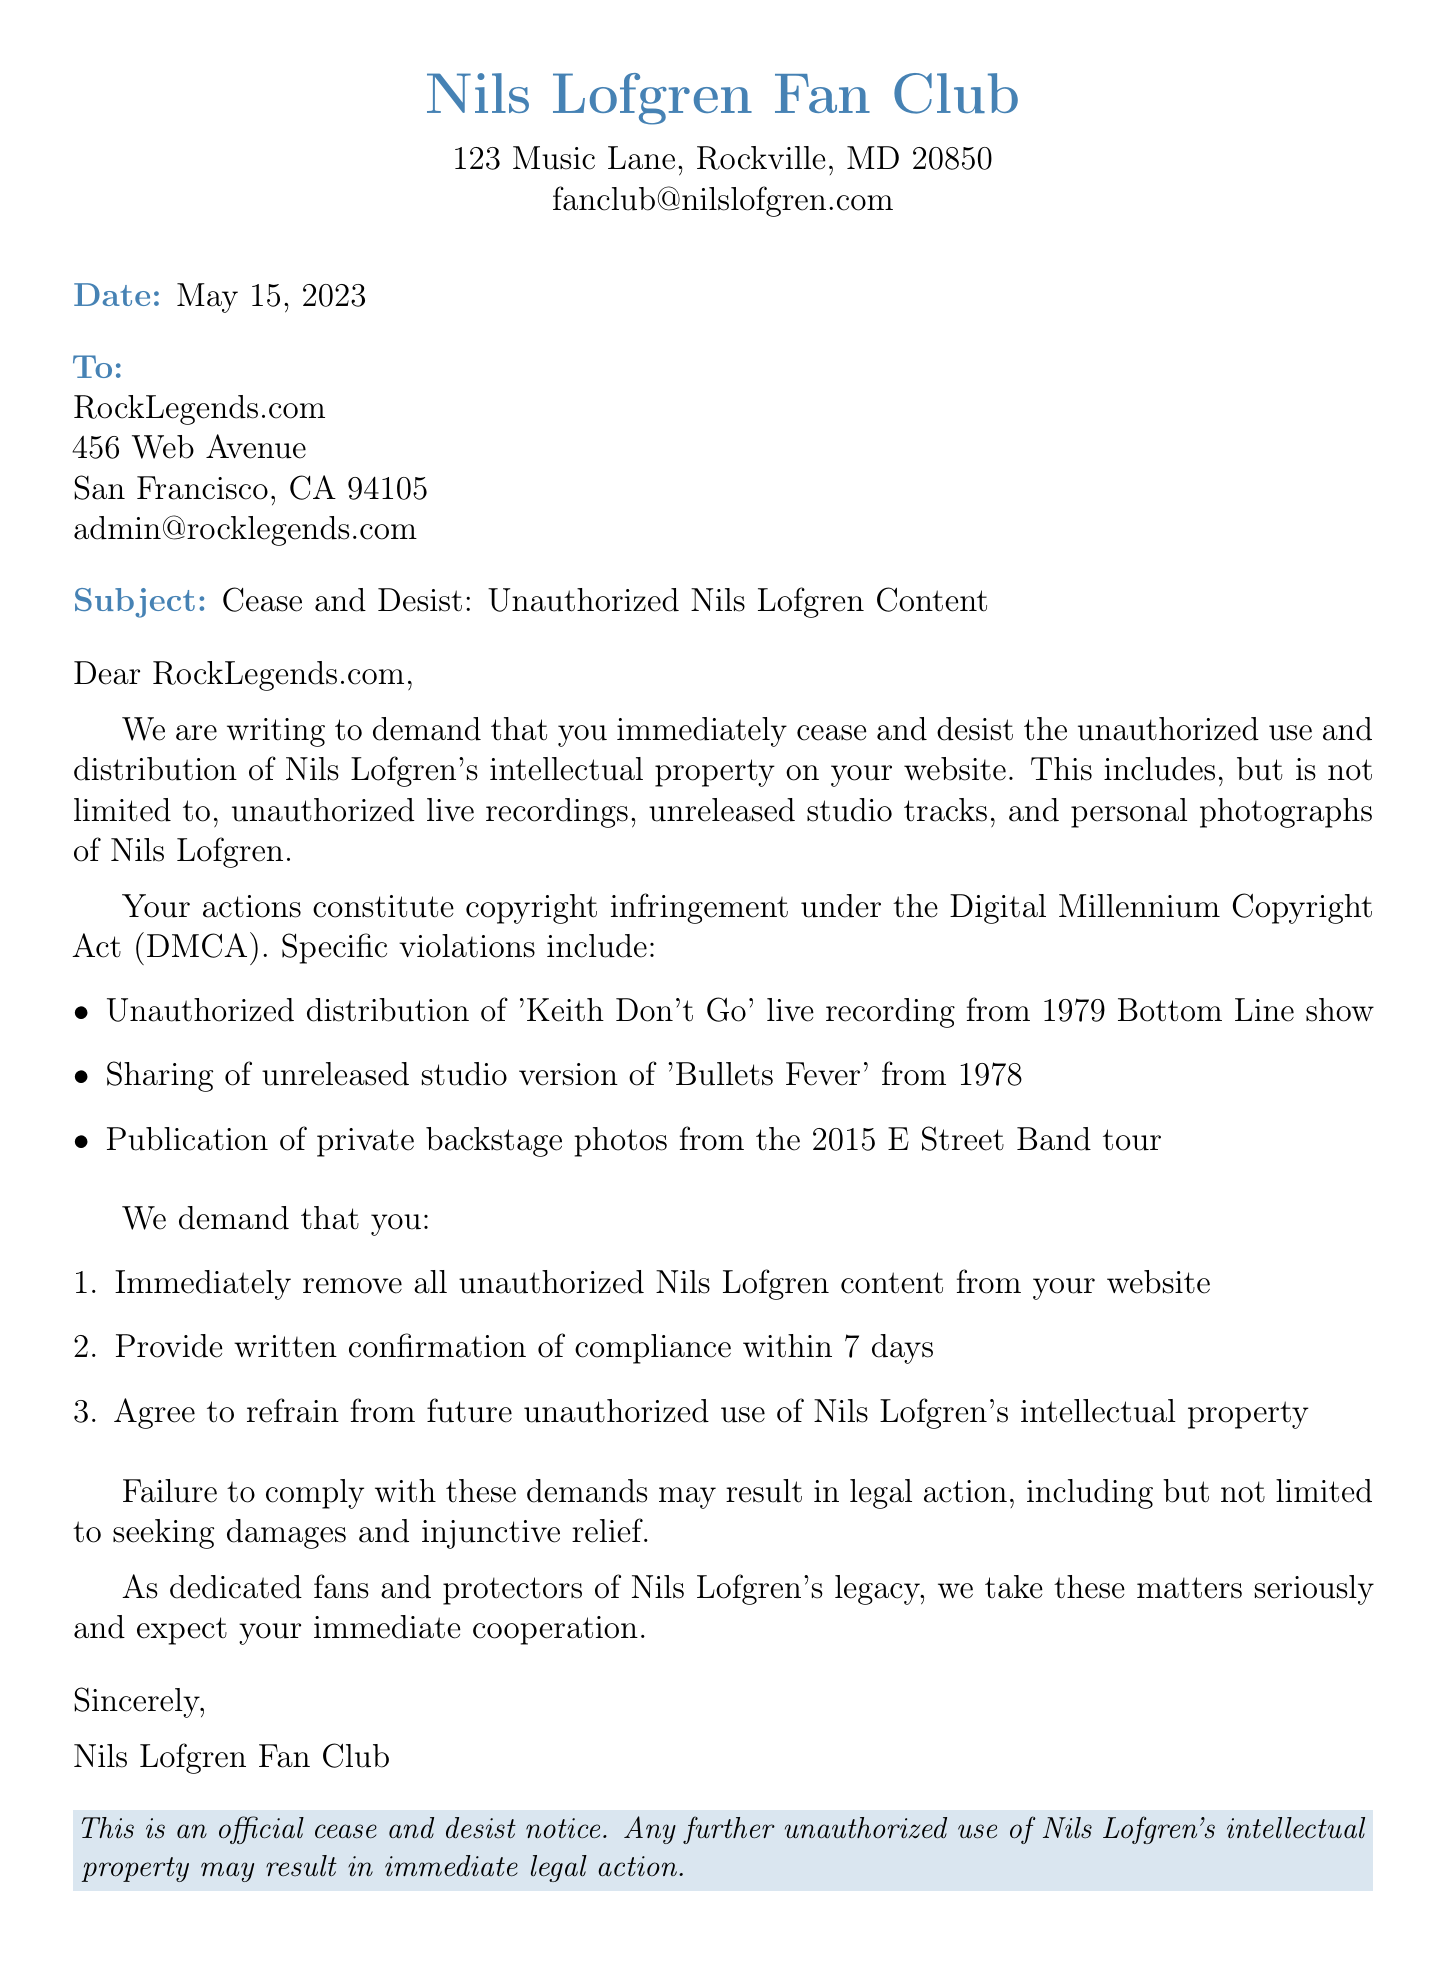What is the sender's name? The sender's name is listed at the top of the document as "Nils Lofgren Fan Club".
Answer: Nils Lofgren Fan Club What is the date of the cease and desist letter? The date is indicated prominently in the document, which states "May 15, 2023".
Answer: May 15, 2023 What is the subject of the letter? The subject line clearly states, "Cease and Desist: Unauthorized Nils Lofgren Content".
Answer: Cease and Desist: Unauthorized Nils Lofgren Content What content is being requested for removal? The document details specific types of content, including "Unauthorized live recordings, unreleased studio tracks, and personal photographs of Nils Lofgren".
Answer: Unauthorized live recordings, unreleased studio tracks, and personal photographs of Nils Lofgren What is the legal basis cited in the letter? The letter mentions "Copyright infringement under the Digital Millennium Copyright Act (DMCA)" as the legal basis.
Answer: Copyright infringement under the Digital Millennium Copyright Act (DMCA) How many days are allowed for compliance confirmation? The letter requests a category of response to be received within "7 days" after the demands.
Answer: 7 days What is the consequence of failing to comply? The document outlines that the consequence includes "Legal action, including but not limited to seeking damages and injunctive relief".
Answer: Legal action What constitutes the specific violation about 'Keith Don't Go'? It specifically mentions "Unauthorized distribution of 'Keith Don't Go' live recording from 1979 Bottom Line show".
Answer: Unauthorized distribution of 'Keith Don't Go' live recording from 1979 Bottom Line show What does the closing statement emphasize? The closing statement highlights the intention and seriousness of the action regarding Nils Lofgren's legacy: "we take these matters seriously".
Answer: we take these matters seriously 